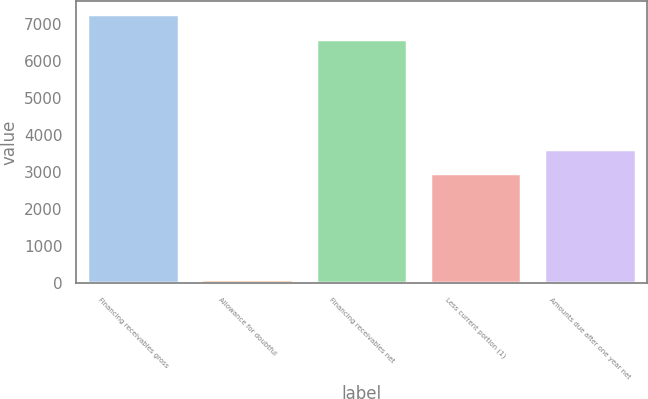<chart> <loc_0><loc_0><loc_500><loc_500><bar_chart><fcel>Financing receivables gross<fcel>Allowance for doubtful<fcel>Financing receivables net<fcel>Less current portion (1)<fcel>Amounts due after one year net<nl><fcel>7267.7<fcel>111<fcel>6607<fcel>2974<fcel>3634.7<nl></chart> 